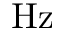Convert formula to latex. <formula><loc_0><loc_0><loc_500><loc_500>H z</formula> 